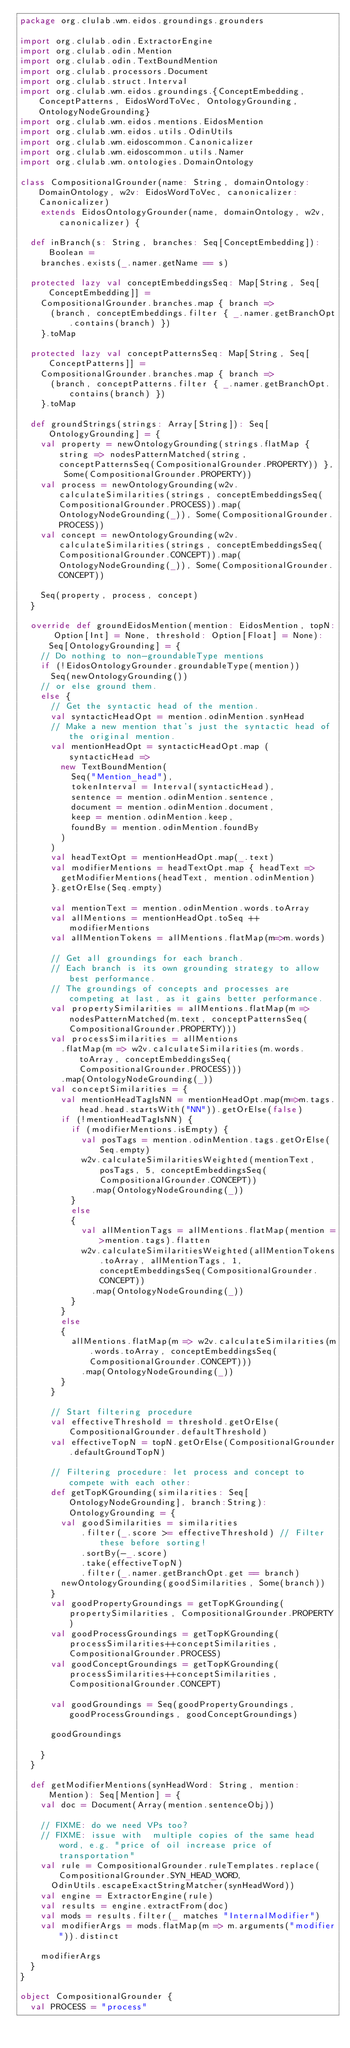<code> <loc_0><loc_0><loc_500><loc_500><_Scala_>package org.clulab.wm.eidos.groundings.grounders

import org.clulab.odin.ExtractorEngine
import org.clulab.odin.Mention
import org.clulab.odin.TextBoundMention
import org.clulab.processors.Document
import org.clulab.struct.Interval
import org.clulab.wm.eidos.groundings.{ConceptEmbedding, ConceptPatterns, EidosWordToVec, OntologyGrounding, OntologyNodeGrounding}
import org.clulab.wm.eidos.mentions.EidosMention
import org.clulab.wm.eidos.utils.OdinUtils
import org.clulab.wm.eidoscommon.Canonicalizer
import org.clulab.wm.eidoscommon.utils.Namer
import org.clulab.wm.ontologies.DomainOntology

class CompositionalGrounder(name: String, domainOntology: DomainOntology, w2v: EidosWordToVec, canonicalizer: Canonicalizer)
    extends EidosOntologyGrounder(name, domainOntology, w2v, canonicalizer) {

  def inBranch(s: String, branches: Seq[ConceptEmbedding]): Boolean =
    branches.exists(_.namer.getName == s)

  protected lazy val conceptEmbeddingsSeq: Map[String, Seq[ConceptEmbedding]] =
    CompositionalGrounder.branches.map { branch =>
      (branch, conceptEmbeddings.filter { _.namer.getBranchOpt.contains(branch) })
    }.toMap

  protected lazy val conceptPatternsSeq: Map[String, Seq[ConceptPatterns]] =
    CompositionalGrounder.branches.map { branch =>
      (branch, conceptPatterns.filter { _.namer.getBranchOpt.contains(branch) })
    }.toMap

  def groundStrings(strings: Array[String]): Seq[OntologyGrounding] = {
    val property = newOntologyGrounding(strings.flatMap { string => nodesPatternMatched(string, conceptPatternsSeq(CompositionalGrounder.PROPERTY)) }, Some(CompositionalGrounder.PROPERTY))
    val process = newOntologyGrounding(w2v.calculateSimilarities(strings, conceptEmbeddingsSeq(CompositionalGrounder.PROCESS)).map(OntologyNodeGrounding(_)), Some(CompositionalGrounder.PROCESS))
    val concept = newOntologyGrounding(w2v.calculateSimilarities(strings, conceptEmbeddingsSeq(CompositionalGrounder.CONCEPT)).map(OntologyNodeGrounding(_)), Some(CompositionalGrounder.CONCEPT))

    Seq(property, process, concept)
  }

  override def groundEidosMention(mention: EidosMention, topN: Option[Int] = None, threshold: Option[Float] = None): Seq[OntologyGrounding] = {
    // Do nothing to non-groundableType mentions
    if (!EidosOntologyGrounder.groundableType(mention))
      Seq(newOntologyGrounding())
    // or else ground them.
    else {
      // Get the syntactic head of the mention.
      val syntacticHeadOpt = mention.odinMention.synHead
      // Make a new mention that's just the syntactic head of the original mention.
      val mentionHeadOpt = syntacticHeadOpt.map ( syntacticHead =>
        new TextBoundMention(
          Seq("Mention_head"),
          tokenInterval = Interval(syntacticHead),
          sentence = mention.odinMention.sentence,
          document = mention.odinMention.document,
          keep = mention.odinMention.keep,
          foundBy = mention.odinMention.foundBy
        )
      )
      val headTextOpt = mentionHeadOpt.map(_.text)
      val modifierMentions = headTextOpt.map { headText =>
        getModifierMentions(headText, mention.odinMention)
      }.getOrElse(Seq.empty)

      val mentionText = mention.odinMention.words.toArray
      val allMentions = mentionHeadOpt.toSeq ++ modifierMentions
      val allMentionTokens = allMentions.flatMap(m=>m.words)

      // Get all groundings for each branch.
      // Each branch is its own grounding strategy to allow best performance.
      // The groundings of concepts and processes are competing at last, as it gains better performance.
      val propertySimilarities = allMentions.flatMap(m => nodesPatternMatched(m.text, conceptPatternsSeq(CompositionalGrounder.PROPERTY)))
      val processSimilarities = allMentions
        .flatMap(m => w2v.calculateSimilarities(m.words.toArray, conceptEmbeddingsSeq(CompositionalGrounder.PROCESS)))
        .map(OntologyNodeGrounding(_))
      val conceptSimilarities = {
        val mentionHeadTagIsNN = mentionHeadOpt.map(m=>m.tags.head.head.startsWith("NN")).getOrElse(false)
        if (!mentionHeadTagIsNN) {
          if (modifierMentions.isEmpty) {
            val posTags = mention.odinMention.tags.getOrElse(Seq.empty)
            w2v.calculateSimilaritiesWeighted(mentionText, posTags, 5, conceptEmbeddingsSeq(CompositionalGrounder.CONCEPT))
              .map(OntologyNodeGrounding(_))
          }
          else
          {
            val allMentionTags = allMentions.flatMap(mention =>mention.tags).flatten
            w2v.calculateSimilaritiesWeighted(allMentionTokens.toArray, allMentionTags, 1, conceptEmbeddingsSeq(CompositionalGrounder.CONCEPT))
              .map(OntologyNodeGrounding(_))
          }
        }
        else
        {
          allMentions.flatMap(m => w2v.calculateSimilarities(m.words.toArray, conceptEmbeddingsSeq(CompositionalGrounder.CONCEPT)))
            .map(OntologyNodeGrounding(_))
        }
      }

      // Start filtering procedure
      val effectiveThreshold = threshold.getOrElse(CompositionalGrounder.defaultThreshold)
      val effectiveTopN = topN.getOrElse(CompositionalGrounder.defaultGroundTopN)

      // Filtering procedure: let process and concept to compete with each other:
      def getTopKGrounding(similarities: Seq[OntologyNodeGrounding], branch:String):OntologyGrounding = {
        val goodSimilarities = similarities
            .filter(_.score >= effectiveThreshold) // Filter these before sorting!
            .sortBy(-_.score)
            .take(effectiveTopN)
            .filter(_.namer.getBranchOpt.get == branch)
        newOntologyGrounding(goodSimilarities, Some(branch))
      }
      val goodPropertyGroundings = getTopKGrounding(propertySimilarities, CompositionalGrounder.PROPERTY)
      val goodProcessGroundings = getTopKGrounding(processSimilarities++conceptSimilarities, CompositionalGrounder.PROCESS)
      val goodConceptGroundings = getTopKGrounding(processSimilarities++conceptSimilarities, CompositionalGrounder.CONCEPT)

      val goodGroundings = Seq(goodPropertyGroundings, goodProcessGroundings, goodConceptGroundings)

      goodGroundings

    }
  }

  def getModifierMentions(synHeadWord: String, mention: Mention): Seq[Mention] = {
    val doc = Document(Array(mention.sentenceObj))

    // FIXME: do we need VPs too?
    // FIXME: issue with  multiple copies of the same head word, e.g. "price of oil increase price of transportation"
    val rule = CompositionalGrounder.ruleTemplates.replace(CompositionalGrounder.SYN_HEAD_WORD,
      OdinUtils.escapeExactStringMatcher(synHeadWord))
    val engine = ExtractorEngine(rule)
    val results = engine.extractFrom(doc)
    val mods = results.filter(_ matches "InternalModifier")
    val modifierArgs = mods.flatMap(m => m.arguments("modifier")).distinct

    modifierArgs
  }
}

object CompositionalGrounder {
  val PROCESS = "process"</code> 